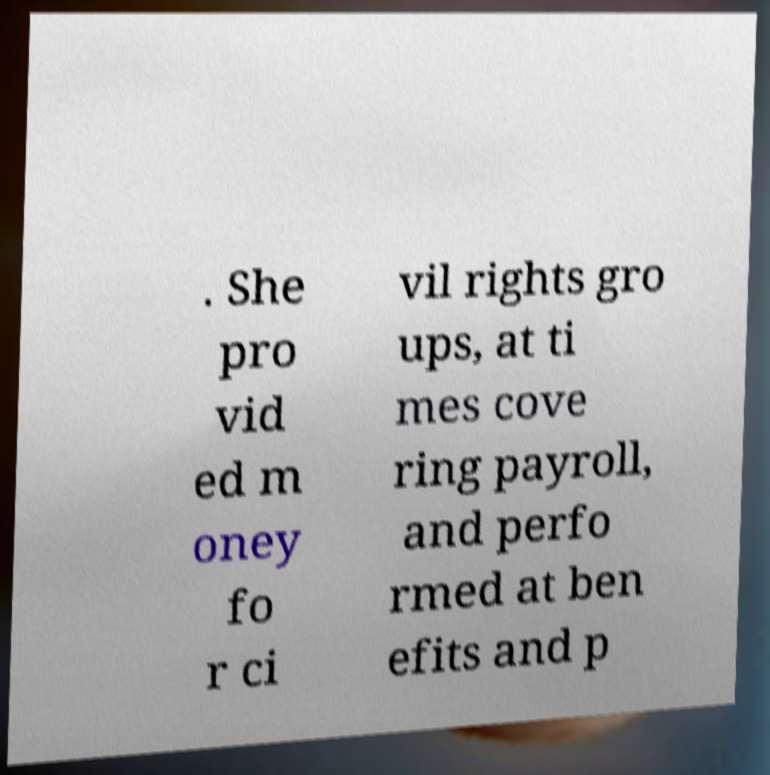I need the written content from this picture converted into text. Can you do that? . She pro vid ed m oney fo r ci vil rights gro ups, at ti mes cove ring payroll, and perfo rmed at ben efits and p 